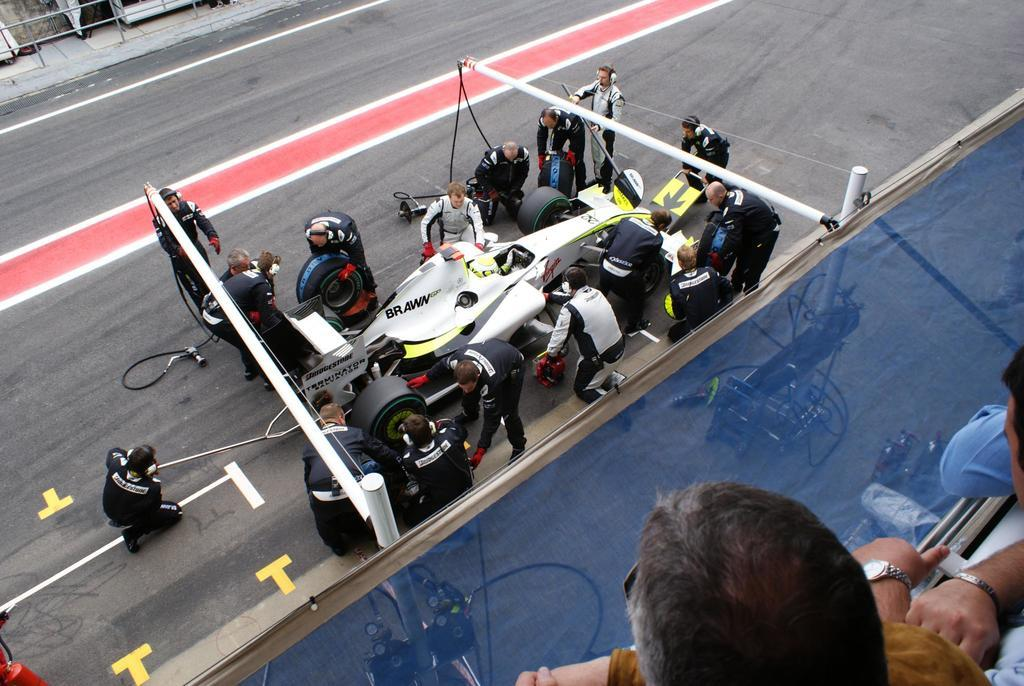What is the main subject of the image? The main subject of the image is a car on the road. What else can be seen in the image besides the car? There is a group of people standing in the image, a rope tied to the car, a pole, and two persons standing at the right bottom of the image. What type of grape is being used to pull the car in the image? There is no grape present in the image, and the car is not being pulled by any grapes. 